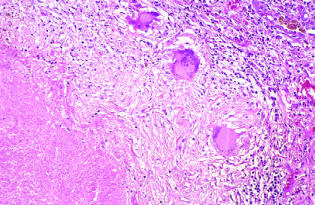does low-power view highlight the histologic features?
Answer the question using a single word or phrase. No 